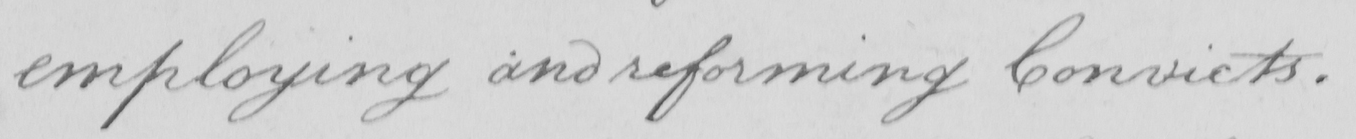Transcribe the text shown in this historical manuscript line. employing and reforming Convicts . 